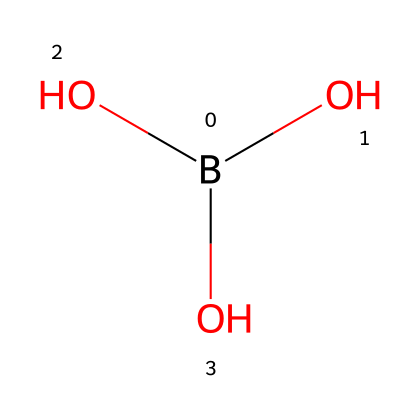What is the name of this chemical? The SMILES representation indicates the presence of a boron atom (B) surrounded by three hydroxyl groups (O). This is characteristic of boric acid.
Answer: boric acid How many oxygen atoms are present in this chemical? The SMILES representation shows three hydroxyl groups, each containing one oxygen atom. Thus, there are three oxygen atoms in the structure.
Answer: three What is the oxidation state of boron in boric acid? Boron typically has an oxidation state of +3. This can be inferred since it is bonded to three oxygen atoms, which are generally in the -2 oxidation state, balancing the overall charge.
Answer: +3 What type of reaction is boric acid commonly used for in soldering? Boric acid is used as a flux in soldering, which helps to clean the surfaces and improve the flow of molten solder.
Answer: flux Why is boric acid effective as a flux in soldering? Boric acid reduces oxidation on metal surfaces, thereby preventing the formation of oxides that would inhibit solder adhesion. It also lowers the melting point of impurities, allowing for a better joint.
Answer: reduces oxidation What is the primary benefit of using boric acid over other fluxes? The primary benefit is that boric acid is less corrosive compared to other fluxes, making it safer for use on sensitive electronic components.
Answer: less corrosive 